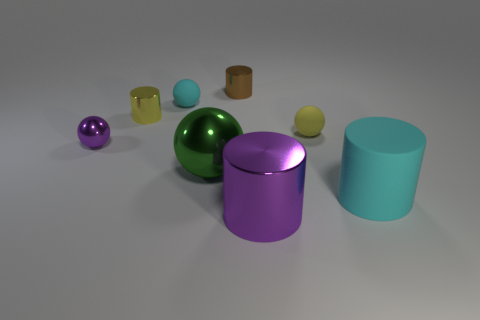Is the material of the purple thing that is right of the brown metal object the same as the cylinder that is to the left of the green thing?
Provide a succinct answer. Yes. How many objects are small balls to the left of the large purple thing or big cyan matte cylinders?
Ensure brevity in your answer.  3. Is the number of metallic cylinders that are on the right side of the tiny yellow sphere less than the number of big objects right of the large cyan thing?
Provide a short and direct response. No. How many other objects are there of the same size as the yellow matte object?
Offer a very short reply. 4. Are the big purple object and the cylinder behind the cyan sphere made of the same material?
Offer a terse response. Yes. What number of objects are big objects that are to the right of the large green sphere or shiny cylinders that are in front of the yellow matte sphere?
Ensure brevity in your answer.  2. What color is the large metallic ball?
Ensure brevity in your answer.  Green. Is the number of small shiny cylinders behind the brown cylinder less than the number of large blue spheres?
Keep it short and to the point. No. Is there any other thing that has the same shape as the tiny purple thing?
Ensure brevity in your answer.  Yes. Are any big green objects visible?
Offer a terse response. Yes. 